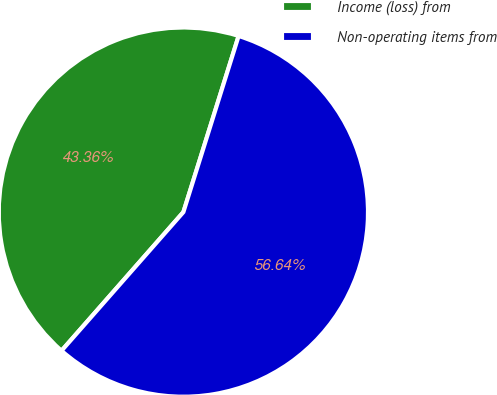Convert chart to OTSL. <chart><loc_0><loc_0><loc_500><loc_500><pie_chart><fcel>Income (loss) from<fcel>Non-operating items from<nl><fcel>43.36%<fcel>56.64%<nl></chart> 